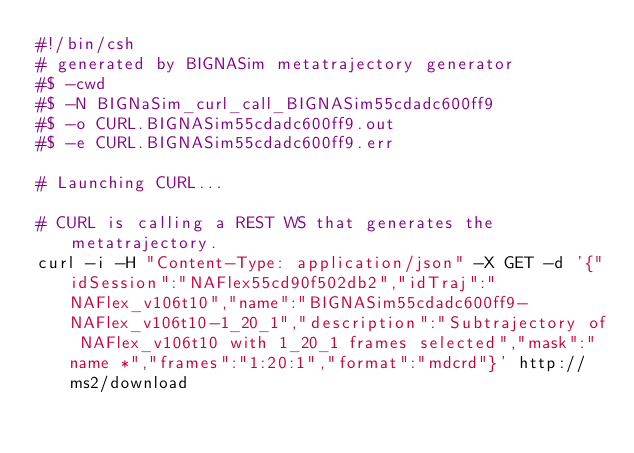<code> <loc_0><loc_0><loc_500><loc_500><_Bash_>#!/bin/csh
# generated by BIGNASim metatrajectory generator
#$ -cwd
#$ -N BIGNaSim_curl_call_BIGNASim55cdadc600ff9
#$ -o CURL.BIGNASim55cdadc600ff9.out
#$ -e CURL.BIGNASim55cdadc600ff9.err

# Launching CURL...

# CURL is calling a REST WS that generates the metatrajectory.
curl -i -H "Content-Type: application/json" -X GET -d '{"idSession":"NAFlex55cd90f502db2","idTraj":"NAFlex_v106t10","name":"BIGNASim55cdadc600ff9-NAFlex_v106t10-1_20_1","description":"Subtrajectory of NAFlex_v106t10 with 1_20_1 frames selected","mask":"name *","frames":"1:20:1","format":"mdcrd"}' http://ms2/download
</code> 